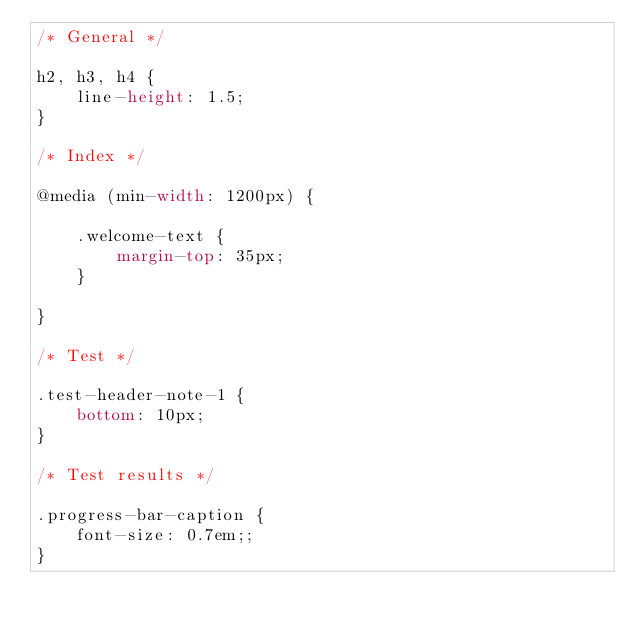<code> <loc_0><loc_0><loc_500><loc_500><_CSS_>/* General */

h2, h3, h4 {
    line-height: 1.5;
}

/* Index */

@media (min-width: 1200px) {

    .welcome-text {
        margin-top: 35px;
    }

}

/* Test */

.test-header-note-1 {
    bottom: 10px;
}

/* Test results */

.progress-bar-caption {
    font-size: 0.7em;;
}</code> 